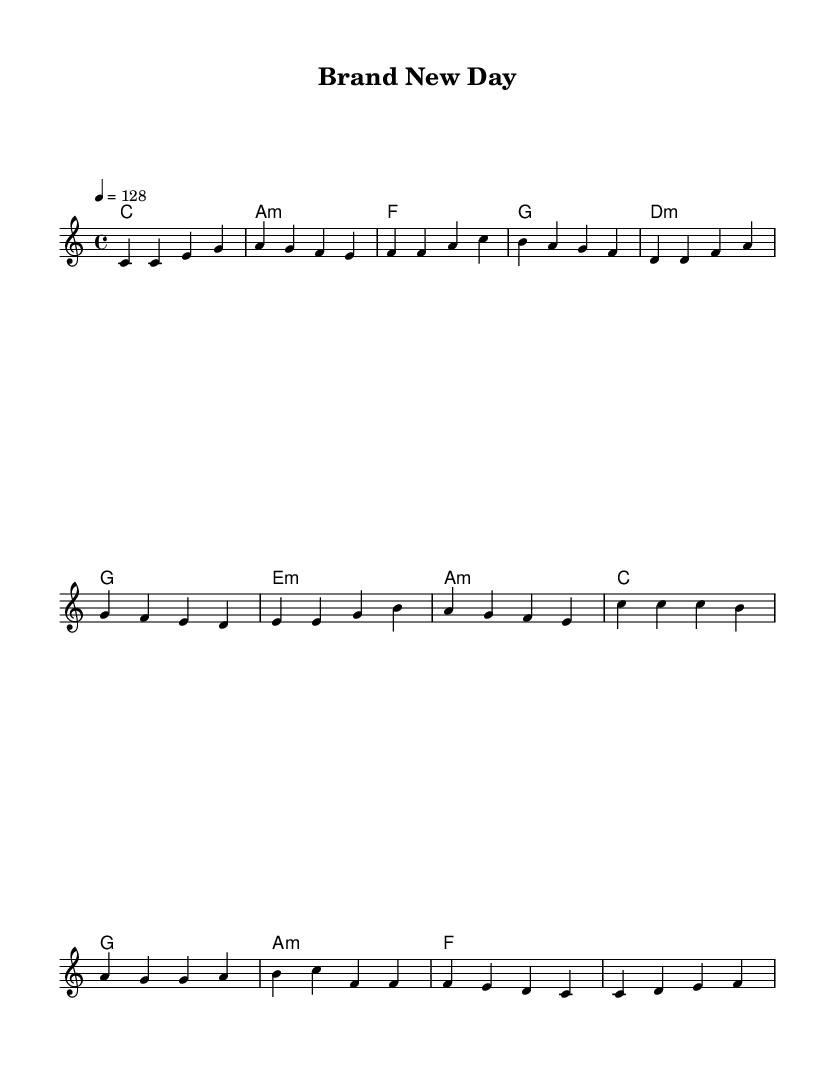What is the key signature of this music? The key signature is indicated at the beginning of the music. Here, there are no sharps or flats shown, meaning it is in the key of C major.
Answer: C major What is the time signature of this music? The time signature is specified at the start of the sheet music. In this case, it is written as 4/4, which means there are four beats in a measure and the quarter note gets one beat.
Answer: 4/4 What is the tempo marking for this music? The tempo is noted as 4 = 128, which signifies that there are 128 beats per minute and the quarter note equals one beat. This is a measure of the speed of the music.
Answer: 128 How many measures are in the verse section? By counting the bars in the melody for the verse, we can see that there are four measures present in the verse section. Each measure is separated by a vertical line in the music notation.
Answer: 4 What types of chords are used in the pre-chorus? Looking at the chord progression in the pre-chorus, we can identify minor chords: d minor, e minor, and a minor are used, along with a G chord. This mix indicates a pop structure supporting the melody.
Answer: D minor, E minor, A minor, G What is the lyrical theme of the chorus? The lyrics in the chorus describe enthusiasm about a campaign launching, capturing the spirit of success and positivity, which is common in catchy pop anthems celebrating brand achievements.
Answer: Successful brand campaigns What is the relationship between the chorus and the verse in terms of melody? The chorus features a melodic rise and more varied notes compared to the verse, creating a contrast that emphasizes the excitement of the campaign. This pattern is typical in pop music to highlight the main message.
Answer: More varied notes 